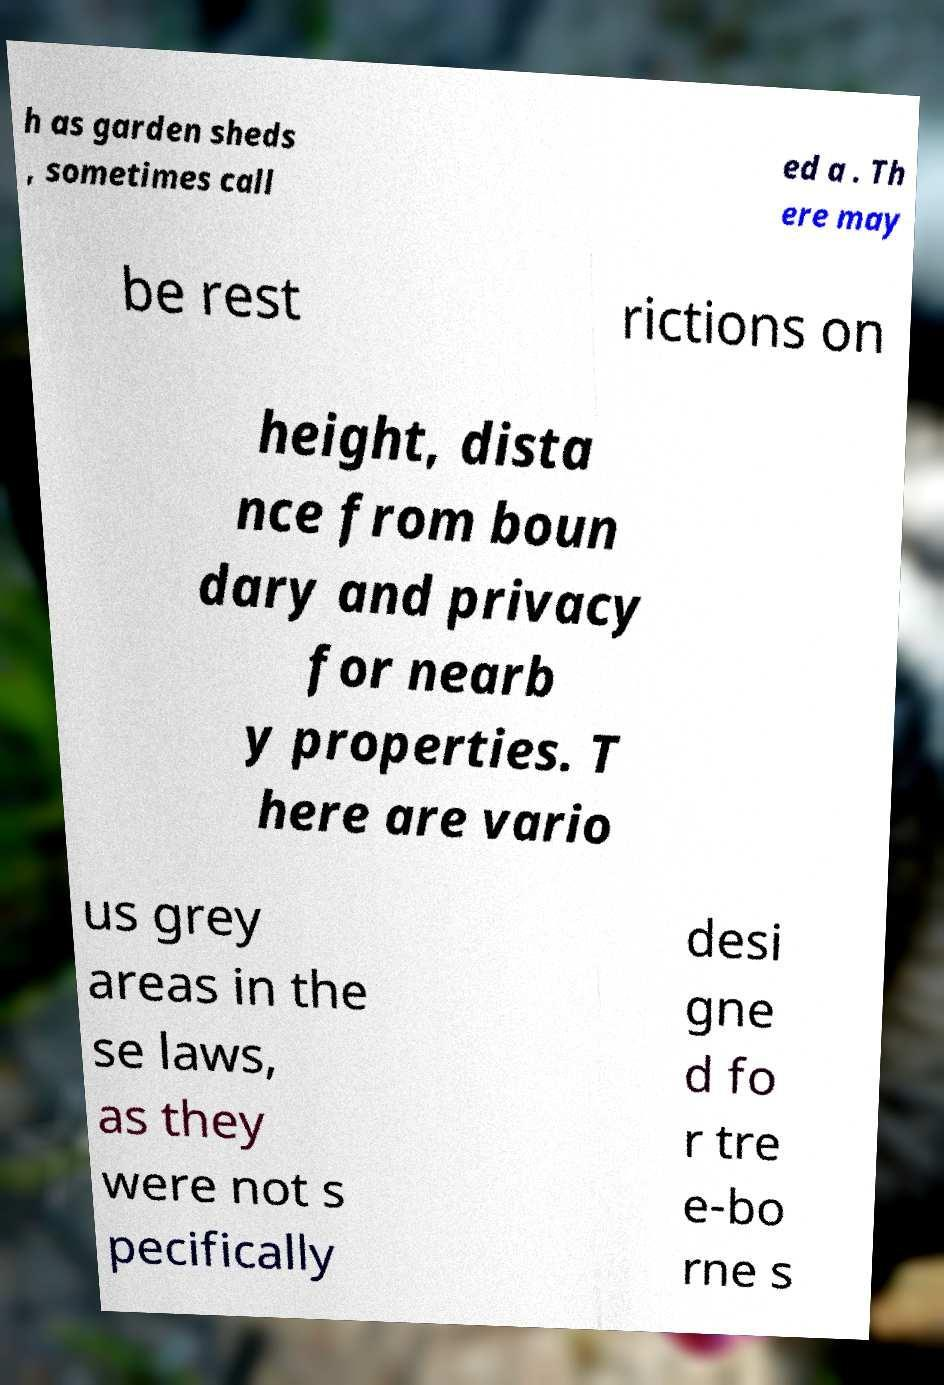There's text embedded in this image that I need extracted. Can you transcribe it verbatim? h as garden sheds , sometimes call ed a . Th ere may be rest rictions on height, dista nce from boun dary and privacy for nearb y properties. T here are vario us grey areas in the se laws, as they were not s pecifically desi gne d fo r tre e-bo rne s 